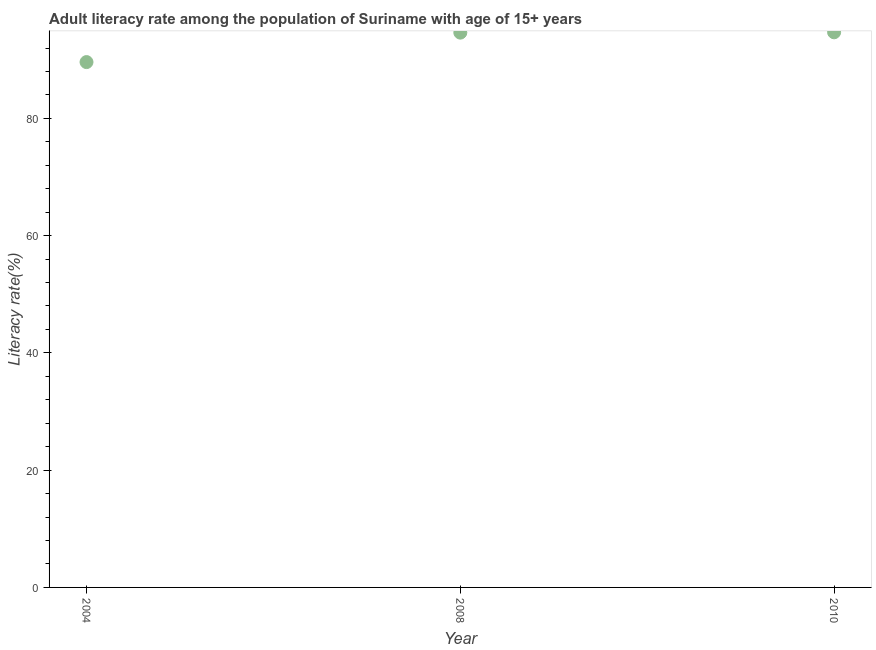What is the adult literacy rate in 2008?
Your response must be concise. 94.62. Across all years, what is the maximum adult literacy rate?
Your answer should be compact. 94.68. Across all years, what is the minimum adult literacy rate?
Your answer should be compact. 89.6. In which year was the adult literacy rate maximum?
Provide a succinct answer. 2010. What is the sum of the adult literacy rate?
Provide a succinct answer. 278.89. What is the difference between the adult literacy rate in 2004 and 2008?
Offer a very short reply. -5.02. What is the average adult literacy rate per year?
Provide a short and direct response. 92.96. What is the median adult literacy rate?
Provide a succinct answer. 94.62. In how many years, is the adult literacy rate greater than 68 %?
Provide a short and direct response. 3. Do a majority of the years between 2004 and 2008 (inclusive) have adult literacy rate greater than 80 %?
Your answer should be compact. Yes. What is the ratio of the adult literacy rate in 2004 to that in 2008?
Keep it short and to the point. 0.95. Is the difference between the adult literacy rate in 2008 and 2010 greater than the difference between any two years?
Provide a succinct answer. No. What is the difference between the highest and the second highest adult literacy rate?
Make the answer very short. 0.05. Is the sum of the adult literacy rate in 2008 and 2010 greater than the maximum adult literacy rate across all years?
Your answer should be compact. Yes. What is the difference between the highest and the lowest adult literacy rate?
Your answer should be very brief. 5.08. In how many years, is the adult literacy rate greater than the average adult literacy rate taken over all years?
Keep it short and to the point. 2. Does the adult literacy rate monotonically increase over the years?
Provide a succinct answer. Yes. Are the values on the major ticks of Y-axis written in scientific E-notation?
Give a very brief answer. No. Does the graph contain any zero values?
Give a very brief answer. No. What is the title of the graph?
Provide a succinct answer. Adult literacy rate among the population of Suriname with age of 15+ years. What is the label or title of the X-axis?
Ensure brevity in your answer.  Year. What is the label or title of the Y-axis?
Make the answer very short. Literacy rate(%). What is the Literacy rate(%) in 2004?
Ensure brevity in your answer.  89.6. What is the Literacy rate(%) in 2008?
Make the answer very short. 94.62. What is the Literacy rate(%) in 2010?
Offer a terse response. 94.68. What is the difference between the Literacy rate(%) in 2004 and 2008?
Keep it short and to the point. -5.02. What is the difference between the Literacy rate(%) in 2004 and 2010?
Make the answer very short. -5.08. What is the difference between the Literacy rate(%) in 2008 and 2010?
Give a very brief answer. -0.05. What is the ratio of the Literacy rate(%) in 2004 to that in 2008?
Offer a very short reply. 0.95. What is the ratio of the Literacy rate(%) in 2004 to that in 2010?
Offer a terse response. 0.95. What is the ratio of the Literacy rate(%) in 2008 to that in 2010?
Offer a very short reply. 1. 